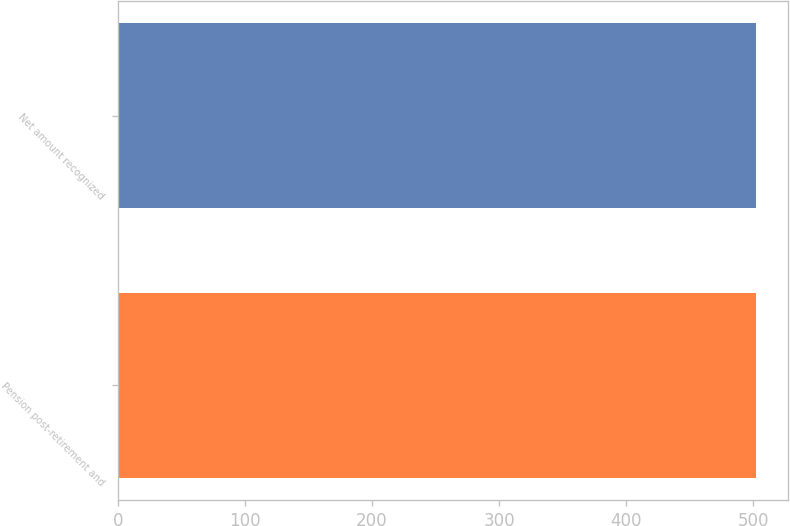<chart> <loc_0><loc_0><loc_500><loc_500><bar_chart><fcel>Pension post-retirement and<fcel>Net amount recognized<nl><fcel>502<fcel>502.1<nl></chart> 